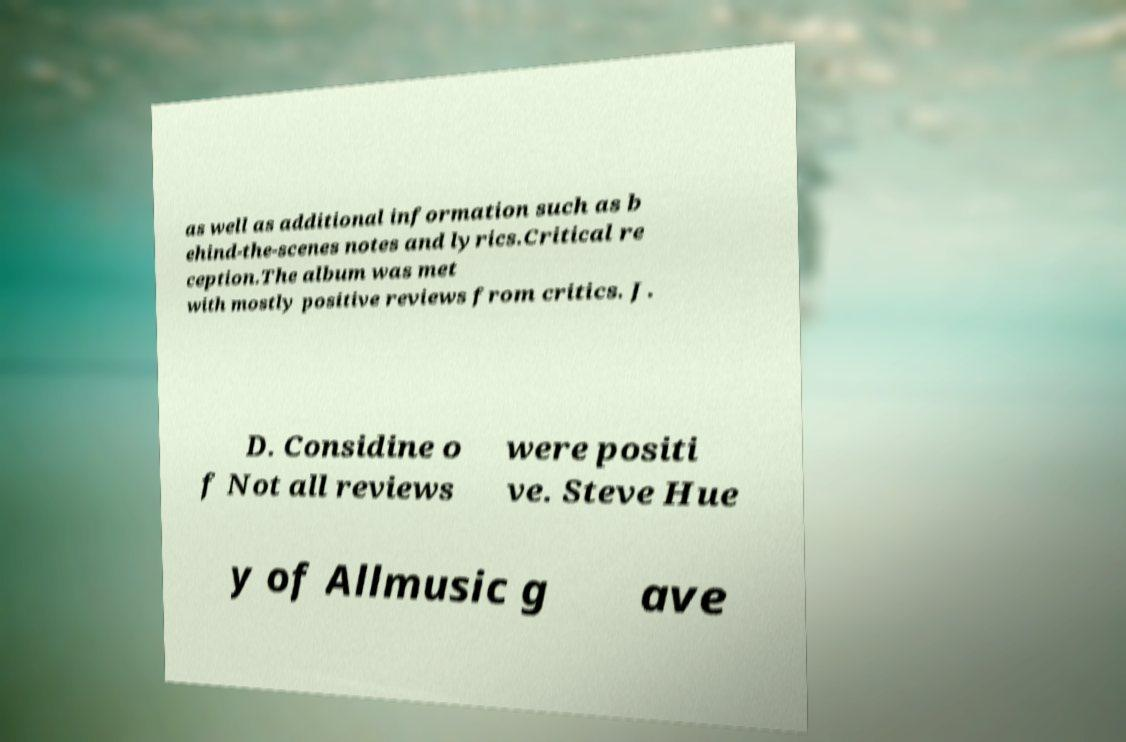Please identify and transcribe the text found in this image. as well as additional information such as b ehind-the-scenes notes and lyrics.Critical re ception.The album was met with mostly positive reviews from critics. J. D. Considine o f Not all reviews were positi ve. Steve Hue y of Allmusic g ave 